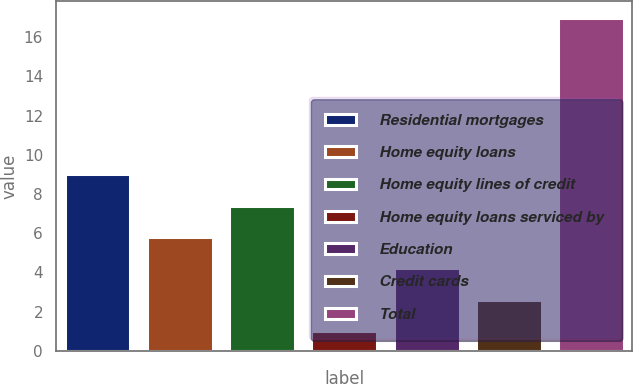Convert chart. <chart><loc_0><loc_0><loc_500><loc_500><bar_chart><fcel>Residential mortgages<fcel>Home equity loans<fcel>Home equity lines of credit<fcel>Home equity loans serviced by<fcel>Education<fcel>Credit cards<fcel>Total<nl><fcel>9<fcel>5.8<fcel>7.4<fcel>1<fcel>4.2<fcel>2.6<fcel>17<nl></chart> 